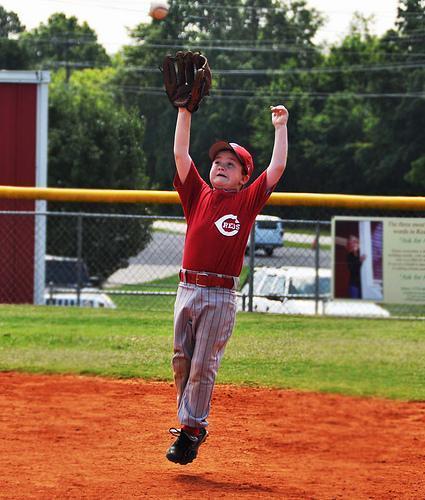How many cars are in the photo?
Give a very brief answer. 2. How many zebras are there?
Give a very brief answer. 0. 